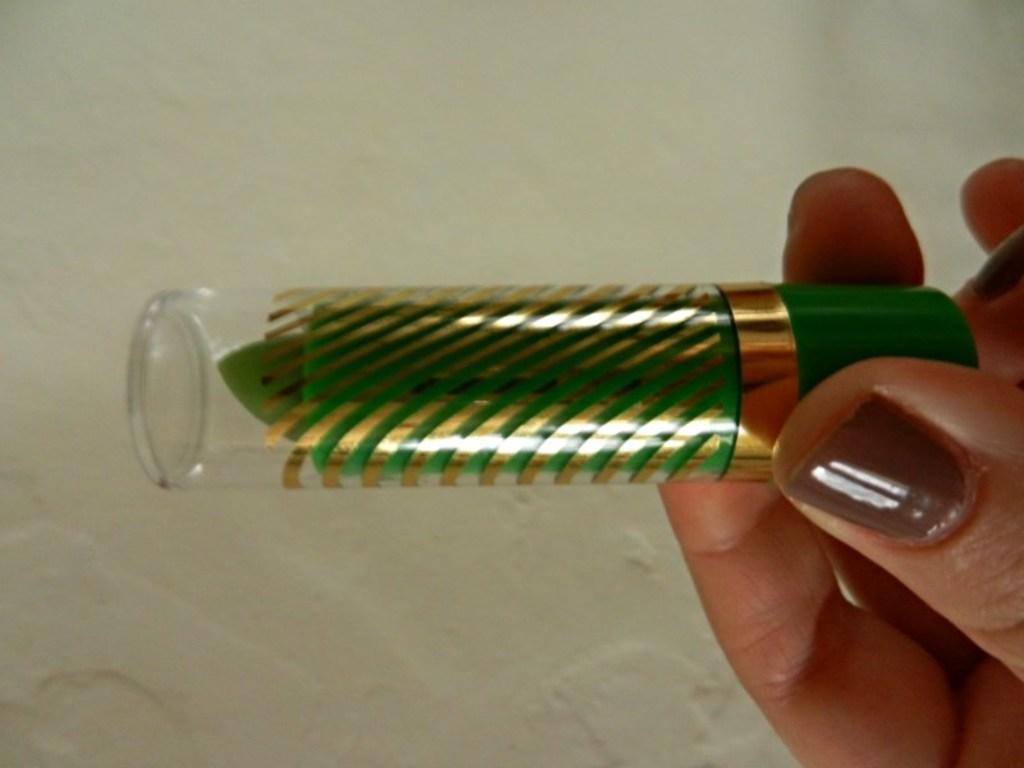What is present in the image that belongs to a person? There is a human hand in the image. What is the hand holding in the image? The hand is holding a green color lipstick. What can be seen behind the hand in the image? There is a wall in the background of the image. What type of cloth is being used to cover the lipstick in the image? There is no cloth present in the image, and the lipstick is not being covered. 